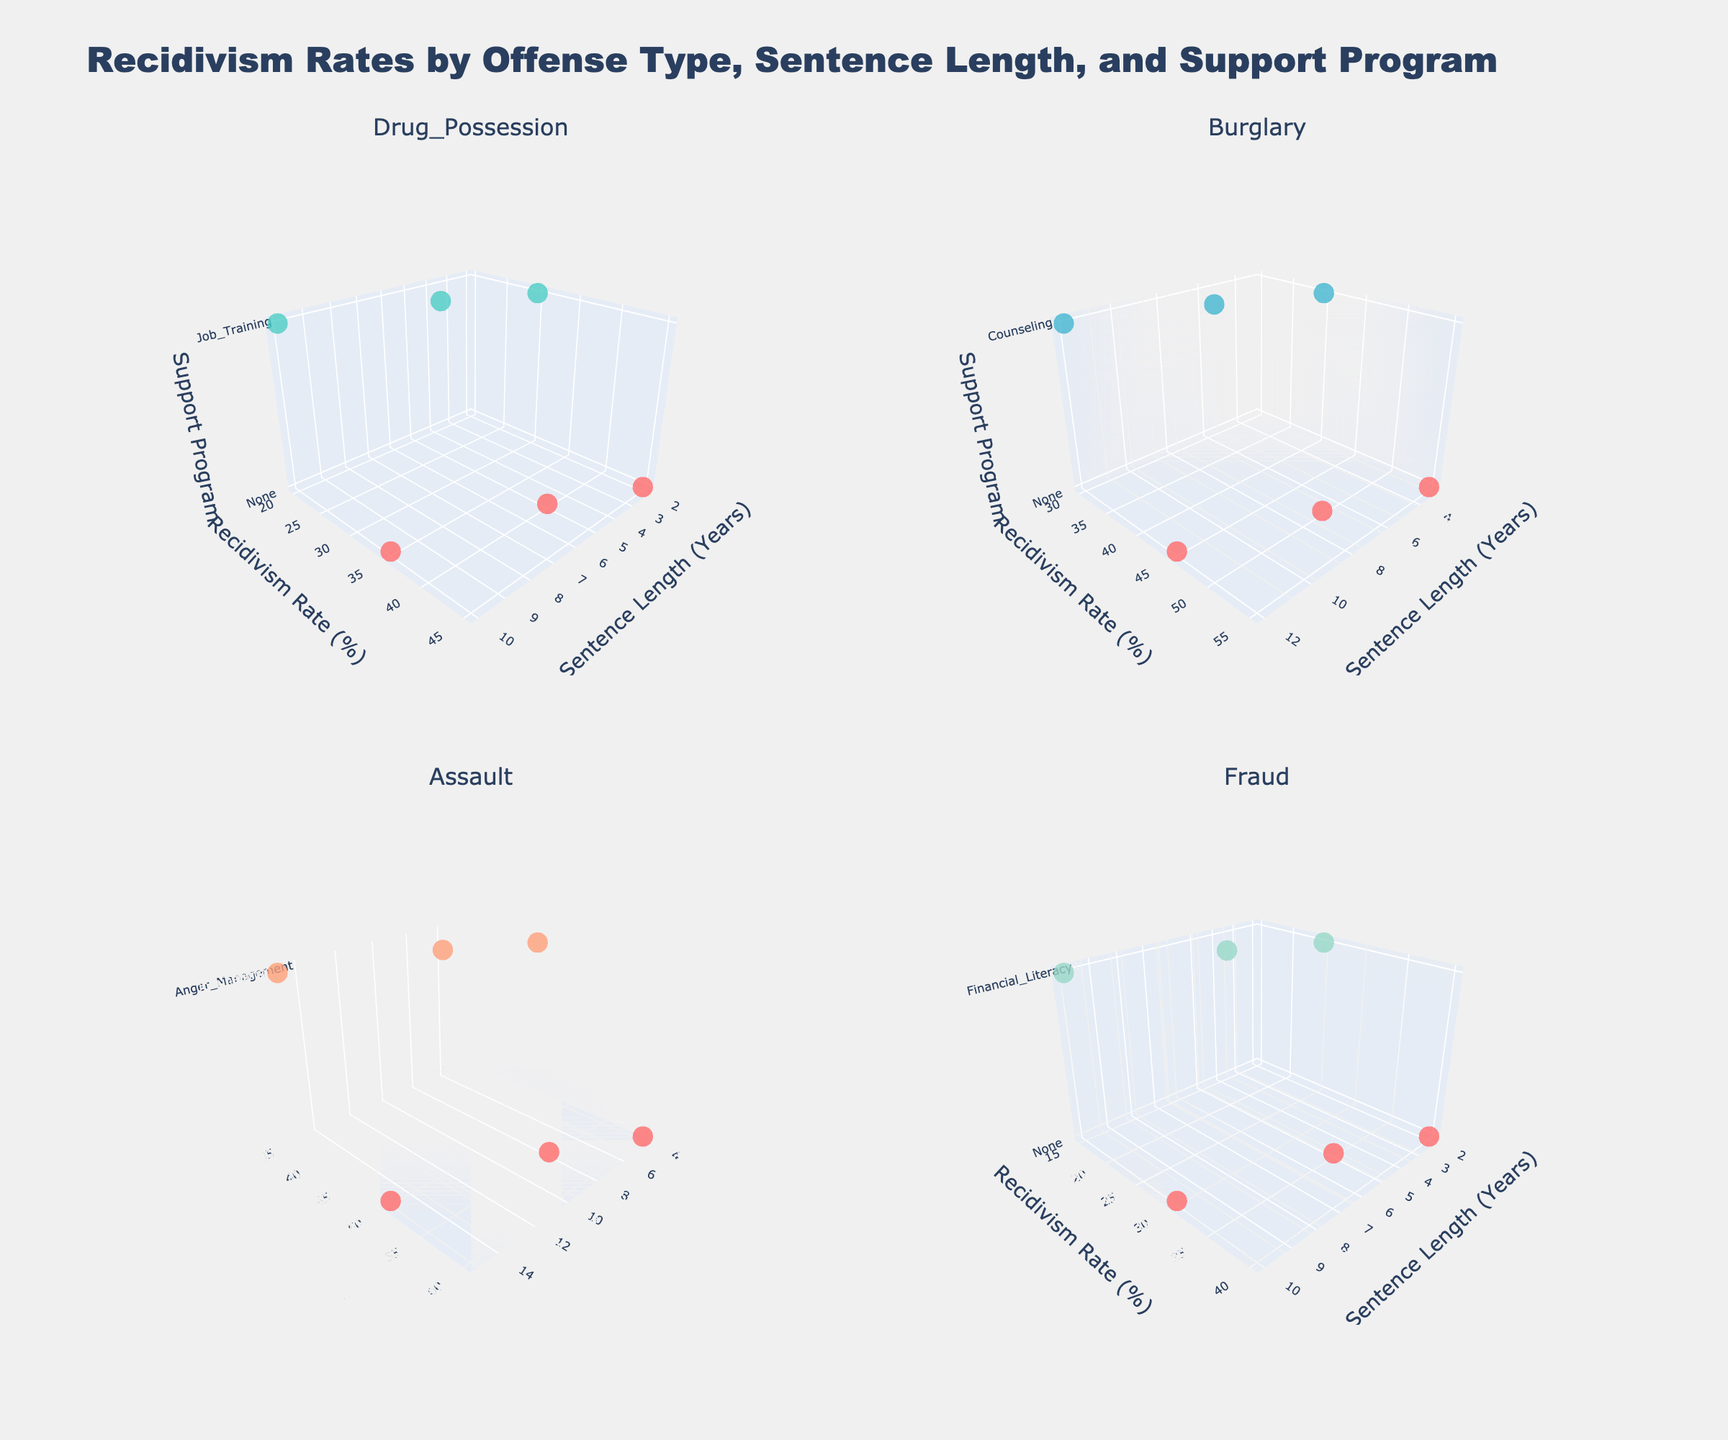What's the overall title of the subplot figure? The title is given in the layout of the plot and is usually located at the top center. It summarizes the entire figure's content
Answer: Recidivism Rates by Offense Type, Sentence Length, and Support Program How many different offense types are analyzed in the plots? The subplot titles indicate each offense type represented in the figure. There are four plots, each representing one offense type
Answer: 4 What does the horizontal axis represent in these plots? The horizontal axis is labeled for each subplot and is consistent across all of them, showing the length of sentences in years
Answer: Sentence Length (Years) Which support program shows the lowest recidivism rate for Assault? By looking at the Assault plot and identifying the lowest point on the vertical axis, we can find which program corresponds to the lowest recidivism rate
Answer: Anger Management Considering the Burglary offense, which sentence length shows a visible drop in recidivism rate with the introduction of a support program? Check the Burglary plot and compare the markers for different sentence lengths with and without support programs, finding the largest drop
Answer: 3 years For Drug Possession, how much does the recidivism rate decrease between 5 years of sentence length with and without Job Training? Identify the markers for 5 years in the Drug Possession plot, note the recidivism rates for Job Training and no program, then calculate the difference
Answer: 15% Which offense type exhibits the highest overall recidivism rate under any condition? Examine each subplot and identify the maximum recidivism rate shown by data points across all offense types
Answer: Assault Is there any offense type where Financial Literacy is one of the support programs shown? Scan through each subplot, particularly focusing on the z-axis labels for support programs, to see if Financial Literacy appears
Answer: Yes, Fraud What trend can be observed in the Fraud subplot regarding recidivism rates and sentence lengths for those receiving Financial Literacy support? Look at the Fraud subplot and track the recidivism rates across different sentence lengths for the Financial Literacy program, noting the direction of the trend
Answer: The recidivism rate decreases as sentence length increases 